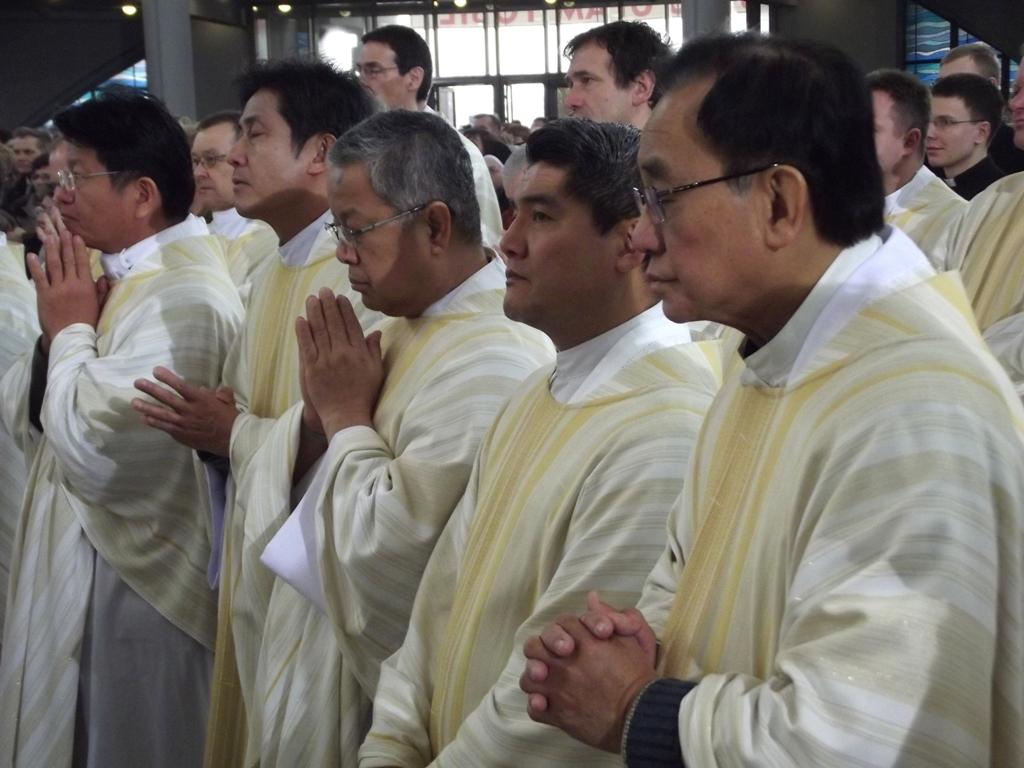What can be seen in the image? There is a group of people in the image. What are the people wearing? The people are wearing white dresses. What are the people doing in the image? The people are doing prayer. What is beside the group of people? There is a glass wall beside the group of people. How does the heat affect the people's prayer in the image? There is no mention of heat in the image, so we cannot determine its effect on the people's prayer. 